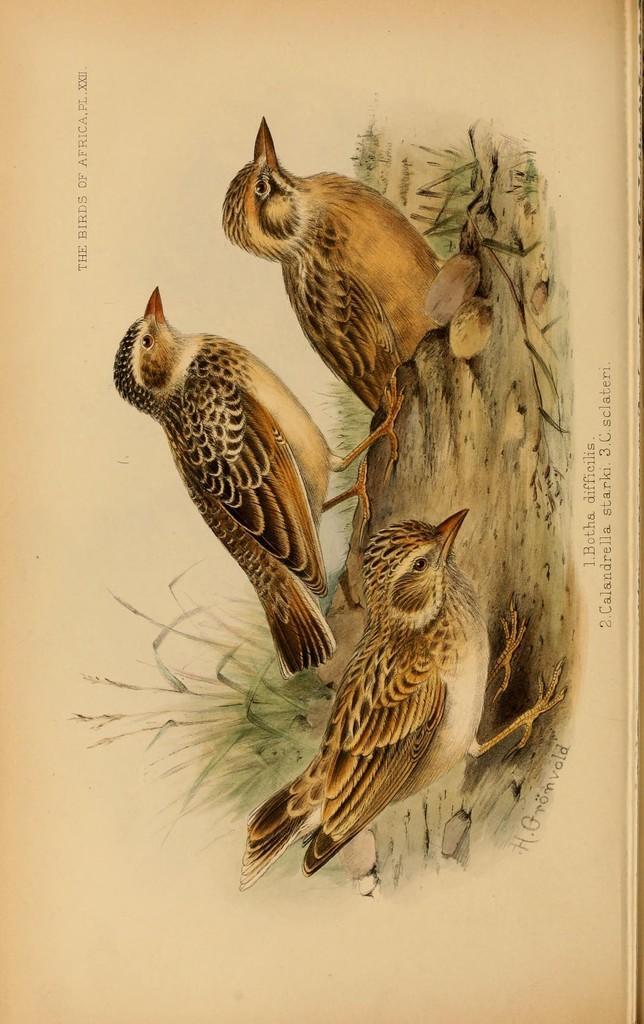How would you summarize this image in a sentence or two? In the image there are pictures of birds and there is some text around the the birds pictures. 